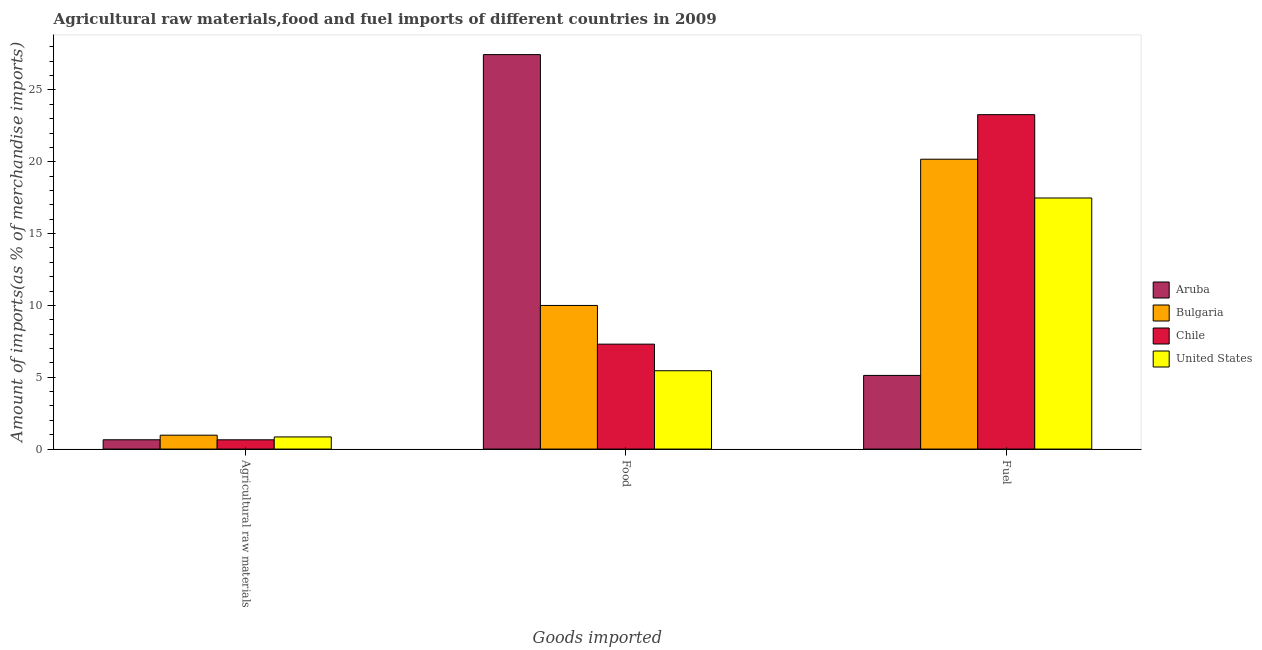How many different coloured bars are there?
Provide a succinct answer. 4. How many groups of bars are there?
Your response must be concise. 3. Are the number of bars per tick equal to the number of legend labels?
Keep it short and to the point. Yes. Are the number of bars on each tick of the X-axis equal?
Offer a terse response. Yes. How many bars are there on the 3rd tick from the left?
Keep it short and to the point. 4. What is the label of the 1st group of bars from the left?
Your response must be concise. Agricultural raw materials. What is the percentage of fuel imports in United States?
Provide a short and direct response. 17.48. Across all countries, what is the maximum percentage of raw materials imports?
Offer a very short reply. 0.97. Across all countries, what is the minimum percentage of food imports?
Give a very brief answer. 5.45. In which country was the percentage of food imports maximum?
Offer a very short reply. Aruba. In which country was the percentage of fuel imports minimum?
Ensure brevity in your answer.  Aruba. What is the total percentage of fuel imports in the graph?
Provide a short and direct response. 66.06. What is the difference between the percentage of fuel imports in Bulgaria and that in Chile?
Your answer should be very brief. -3.1. What is the difference between the percentage of fuel imports in United States and the percentage of raw materials imports in Bulgaria?
Offer a terse response. 16.51. What is the average percentage of fuel imports per country?
Your answer should be compact. 16.51. What is the difference between the percentage of raw materials imports and percentage of food imports in Bulgaria?
Offer a terse response. -9.03. What is the ratio of the percentage of fuel imports in Bulgaria to that in United States?
Offer a terse response. 1.15. What is the difference between the highest and the second highest percentage of fuel imports?
Give a very brief answer. 3.1. What is the difference between the highest and the lowest percentage of food imports?
Ensure brevity in your answer.  22.01. Is the sum of the percentage of raw materials imports in Bulgaria and Aruba greater than the maximum percentage of fuel imports across all countries?
Provide a short and direct response. No. What does the 4th bar from the right in Fuel represents?
Provide a succinct answer. Aruba. Is it the case that in every country, the sum of the percentage of raw materials imports and percentage of food imports is greater than the percentage of fuel imports?
Your answer should be very brief. No. How many bars are there?
Give a very brief answer. 12. Are all the bars in the graph horizontal?
Make the answer very short. No. What is the difference between two consecutive major ticks on the Y-axis?
Offer a very short reply. 5. Are the values on the major ticks of Y-axis written in scientific E-notation?
Offer a terse response. No. What is the title of the graph?
Offer a very short reply. Agricultural raw materials,food and fuel imports of different countries in 2009. Does "Afghanistan" appear as one of the legend labels in the graph?
Offer a terse response. No. What is the label or title of the X-axis?
Keep it short and to the point. Goods imported. What is the label or title of the Y-axis?
Offer a very short reply. Amount of imports(as % of merchandise imports). What is the Amount of imports(as % of merchandise imports) in Aruba in Agricultural raw materials?
Your answer should be very brief. 0.65. What is the Amount of imports(as % of merchandise imports) of Bulgaria in Agricultural raw materials?
Ensure brevity in your answer.  0.97. What is the Amount of imports(as % of merchandise imports) of Chile in Agricultural raw materials?
Your answer should be compact. 0.65. What is the Amount of imports(as % of merchandise imports) of United States in Agricultural raw materials?
Give a very brief answer. 0.85. What is the Amount of imports(as % of merchandise imports) in Aruba in Food?
Offer a very short reply. 27.46. What is the Amount of imports(as % of merchandise imports) in Bulgaria in Food?
Provide a short and direct response. 10. What is the Amount of imports(as % of merchandise imports) of Chile in Food?
Make the answer very short. 7.3. What is the Amount of imports(as % of merchandise imports) in United States in Food?
Provide a succinct answer. 5.45. What is the Amount of imports(as % of merchandise imports) in Aruba in Fuel?
Your answer should be compact. 5.13. What is the Amount of imports(as % of merchandise imports) of Bulgaria in Fuel?
Offer a terse response. 20.18. What is the Amount of imports(as % of merchandise imports) of Chile in Fuel?
Offer a very short reply. 23.28. What is the Amount of imports(as % of merchandise imports) in United States in Fuel?
Keep it short and to the point. 17.48. Across all Goods imported, what is the maximum Amount of imports(as % of merchandise imports) in Aruba?
Provide a short and direct response. 27.46. Across all Goods imported, what is the maximum Amount of imports(as % of merchandise imports) of Bulgaria?
Keep it short and to the point. 20.18. Across all Goods imported, what is the maximum Amount of imports(as % of merchandise imports) in Chile?
Provide a short and direct response. 23.28. Across all Goods imported, what is the maximum Amount of imports(as % of merchandise imports) of United States?
Offer a very short reply. 17.48. Across all Goods imported, what is the minimum Amount of imports(as % of merchandise imports) of Aruba?
Offer a terse response. 0.65. Across all Goods imported, what is the minimum Amount of imports(as % of merchandise imports) in Bulgaria?
Offer a very short reply. 0.97. Across all Goods imported, what is the minimum Amount of imports(as % of merchandise imports) of Chile?
Offer a terse response. 0.65. Across all Goods imported, what is the minimum Amount of imports(as % of merchandise imports) in United States?
Your answer should be compact. 0.85. What is the total Amount of imports(as % of merchandise imports) in Aruba in the graph?
Make the answer very short. 33.23. What is the total Amount of imports(as % of merchandise imports) of Bulgaria in the graph?
Provide a short and direct response. 31.14. What is the total Amount of imports(as % of merchandise imports) in Chile in the graph?
Offer a very short reply. 31.23. What is the total Amount of imports(as % of merchandise imports) of United States in the graph?
Provide a succinct answer. 23.78. What is the difference between the Amount of imports(as % of merchandise imports) of Aruba in Agricultural raw materials and that in Food?
Offer a terse response. -26.81. What is the difference between the Amount of imports(as % of merchandise imports) of Bulgaria in Agricultural raw materials and that in Food?
Offer a very short reply. -9.03. What is the difference between the Amount of imports(as % of merchandise imports) of Chile in Agricultural raw materials and that in Food?
Offer a terse response. -6.66. What is the difference between the Amount of imports(as % of merchandise imports) in United States in Agricultural raw materials and that in Food?
Offer a terse response. -4.61. What is the difference between the Amount of imports(as % of merchandise imports) in Aruba in Agricultural raw materials and that in Fuel?
Your response must be concise. -4.48. What is the difference between the Amount of imports(as % of merchandise imports) of Bulgaria in Agricultural raw materials and that in Fuel?
Your answer should be compact. -19.21. What is the difference between the Amount of imports(as % of merchandise imports) in Chile in Agricultural raw materials and that in Fuel?
Keep it short and to the point. -22.63. What is the difference between the Amount of imports(as % of merchandise imports) in United States in Agricultural raw materials and that in Fuel?
Provide a succinct answer. -16.63. What is the difference between the Amount of imports(as % of merchandise imports) of Aruba in Food and that in Fuel?
Make the answer very short. 22.33. What is the difference between the Amount of imports(as % of merchandise imports) of Bulgaria in Food and that in Fuel?
Give a very brief answer. -10.18. What is the difference between the Amount of imports(as % of merchandise imports) in Chile in Food and that in Fuel?
Keep it short and to the point. -15.97. What is the difference between the Amount of imports(as % of merchandise imports) of United States in Food and that in Fuel?
Your answer should be compact. -12.03. What is the difference between the Amount of imports(as % of merchandise imports) in Aruba in Agricultural raw materials and the Amount of imports(as % of merchandise imports) in Bulgaria in Food?
Provide a succinct answer. -9.35. What is the difference between the Amount of imports(as % of merchandise imports) in Aruba in Agricultural raw materials and the Amount of imports(as % of merchandise imports) in Chile in Food?
Your answer should be very brief. -6.66. What is the difference between the Amount of imports(as % of merchandise imports) in Aruba in Agricultural raw materials and the Amount of imports(as % of merchandise imports) in United States in Food?
Offer a terse response. -4.8. What is the difference between the Amount of imports(as % of merchandise imports) in Bulgaria in Agricultural raw materials and the Amount of imports(as % of merchandise imports) in Chile in Food?
Your answer should be very brief. -6.34. What is the difference between the Amount of imports(as % of merchandise imports) of Bulgaria in Agricultural raw materials and the Amount of imports(as % of merchandise imports) of United States in Food?
Make the answer very short. -4.49. What is the difference between the Amount of imports(as % of merchandise imports) in Chile in Agricultural raw materials and the Amount of imports(as % of merchandise imports) in United States in Food?
Ensure brevity in your answer.  -4.81. What is the difference between the Amount of imports(as % of merchandise imports) of Aruba in Agricultural raw materials and the Amount of imports(as % of merchandise imports) of Bulgaria in Fuel?
Your answer should be compact. -19.53. What is the difference between the Amount of imports(as % of merchandise imports) of Aruba in Agricultural raw materials and the Amount of imports(as % of merchandise imports) of Chile in Fuel?
Ensure brevity in your answer.  -22.63. What is the difference between the Amount of imports(as % of merchandise imports) of Aruba in Agricultural raw materials and the Amount of imports(as % of merchandise imports) of United States in Fuel?
Offer a very short reply. -16.83. What is the difference between the Amount of imports(as % of merchandise imports) in Bulgaria in Agricultural raw materials and the Amount of imports(as % of merchandise imports) in Chile in Fuel?
Give a very brief answer. -22.31. What is the difference between the Amount of imports(as % of merchandise imports) in Bulgaria in Agricultural raw materials and the Amount of imports(as % of merchandise imports) in United States in Fuel?
Your response must be concise. -16.51. What is the difference between the Amount of imports(as % of merchandise imports) in Chile in Agricultural raw materials and the Amount of imports(as % of merchandise imports) in United States in Fuel?
Keep it short and to the point. -16.83. What is the difference between the Amount of imports(as % of merchandise imports) of Aruba in Food and the Amount of imports(as % of merchandise imports) of Bulgaria in Fuel?
Keep it short and to the point. 7.28. What is the difference between the Amount of imports(as % of merchandise imports) in Aruba in Food and the Amount of imports(as % of merchandise imports) in Chile in Fuel?
Your answer should be very brief. 4.18. What is the difference between the Amount of imports(as % of merchandise imports) in Aruba in Food and the Amount of imports(as % of merchandise imports) in United States in Fuel?
Keep it short and to the point. 9.98. What is the difference between the Amount of imports(as % of merchandise imports) of Bulgaria in Food and the Amount of imports(as % of merchandise imports) of Chile in Fuel?
Ensure brevity in your answer.  -13.28. What is the difference between the Amount of imports(as % of merchandise imports) in Bulgaria in Food and the Amount of imports(as % of merchandise imports) in United States in Fuel?
Give a very brief answer. -7.48. What is the difference between the Amount of imports(as % of merchandise imports) in Chile in Food and the Amount of imports(as % of merchandise imports) in United States in Fuel?
Give a very brief answer. -10.17. What is the average Amount of imports(as % of merchandise imports) in Aruba per Goods imported?
Provide a succinct answer. 11.08. What is the average Amount of imports(as % of merchandise imports) of Bulgaria per Goods imported?
Provide a succinct answer. 10.38. What is the average Amount of imports(as % of merchandise imports) in Chile per Goods imported?
Keep it short and to the point. 10.41. What is the average Amount of imports(as % of merchandise imports) of United States per Goods imported?
Your answer should be compact. 7.92. What is the difference between the Amount of imports(as % of merchandise imports) of Aruba and Amount of imports(as % of merchandise imports) of Bulgaria in Agricultural raw materials?
Make the answer very short. -0.32. What is the difference between the Amount of imports(as % of merchandise imports) of Aruba and Amount of imports(as % of merchandise imports) of Chile in Agricultural raw materials?
Your answer should be very brief. 0. What is the difference between the Amount of imports(as % of merchandise imports) in Aruba and Amount of imports(as % of merchandise imports) in United States in Agricultural raw materials?
Ensure brevity in your answer.  -0.2. What is the difference between the Amount of imports(as % of merchandise imports) of Bulgaria and Amount of imports(as % of merchandise imports) of Chile in Agricultural raw materials?
Your answer should be very brief. 0.32. What is the difference between the Amount of imports(as % of merchandise imports) of Bulgaria and Amount of imports(as % of merchandise imports) of United States in Agricultural raw materials?
Your response must be concise. 0.12. What is the difference between the Amount of imports(as % of merchandise imports) in Chile and Amount of imports(as % of merchandise imports) in United States in Agricultural raw materials?
Ensure brevity in your answer.  -0.2. What is the difference between the Amount of imports(as % of merchandise imports) in Aruba and Amount of imports(as % of merchandise imports) in Bulgaria in Food?
Offer a terse response. 17.46. What is the difference between the Amount of imports(as % of merchandise imports) of Aruba and Amount of imports(as % of merchandise imports) of Chile in Food?
Your response must be concise. 20.15. What is the difference between the Amount of imports(as % of merchandise imports) in Aruba and Amount of imports(as % of merchandise imports) in United States in Food?
Your answer should be very brief. 22.01. What is the difference between the Amount of imports(as % of merchandise imports) in Bulgaria and Amount of imports(as % of merchandise imports) in Chile in Food?
Offer a terse response. 2.69. What is the difference between the Amount of imports(as % of merchandise imports) of Bulgaria and Amount of imports(as % of merchandise imports) of United States in Food?
Make the answer very short. 4.55. What is the difference between the Amount of imports(as % of merchandise imports) in Chile and Amount of imports(as % of merchandise imports) in United States in Food?
Provide a short and direct response. 1.85. What is the difference between the Amount of imports(as % of merchandise imports) in Aruba and Amount of imports(as % of merchandise imports) in Bulgaria in Fuel?
Ensure brevity in your answer.  -15.05. What is the difference between the Amount of imports(as % of merchandise imports) in Aruba and Amount of imports(as % of merchandise imports) in Chile in Fuel?
Your answer should be compact. -18.15. What is the difference between the Amount of imports(as % of merchandise imports) of Aruba and Amount of imports(as % of merchandise imports) of United States in Fuel?
Keep it short and to the point. -12.35. What is the difference between the Amount of imports(as % of merchandise imports) of Bulgaria and Amount of imports(as % of merchandise imports) of Chile in Fuel?
Your answer should be very brief. -3.1. What is the difference between the Amount of imports(as % of merchandise imports) in Bulgaria and Amount of imports(as % of merchandise imports) in United States in Fuel?
Keep it short and to the point. 2.7. What is the difference between the Amount of imports(as % of merchandise imports) in Chile and Amount of imports(as % of merchandise imports) in United States in Fuel?
Make the answer very short. 5.8. What is the ratio of the Amount of imports(as % of merchandise imports) of Aruba in Agricultural raw materials to that in Food?
Make the answer very short. 0.02. What is the ratio of the Amount of imports(as % of merchandise imports) in Bulgaria in Agricultural raw materials to that in Food?
Offer a very short reply. 0.1. What is the ratio of the Amount of imports(as % of merchandise imports) in Chile in Agricultural raw materials to that in Food?
Provide a short and direct response. 0.09. What is the ratio of the Amount of imports(as % of merchandise imports) in United States in Agricultural raw materials to that in Food?
Ensure brevity in your answer.  0.16. What is the ratio of the Amount of imports(as % of merchandise imports) in Aruba in Agricultural raw materials to that in Fuel?
Provide a succinct answer. 0.13. What is the ratio of the Amount of imports(as % of merchandise imports) of Bulgaria in Agricultural raw materials to that in Fuel?
Make the answer very short. 0.05. What is the ratio of the Amount of imports(as % of merchandise imports) of Chile in Agricultural raw materials to that in Fuel?
Provide a succinct answer. 0.03. What is the ratio of the Amount of imports(as % of merchandise imports) in United States in Agricultural raw materials to that in Fuel?
Offer a very short reply. 0.05. What is the ratio of the Amount of imports(as % of merchandise imports) of Aruba in Food to that in Fuel?
Your answer should be very brief. 5.36. What is the ratio of the Amount of imports(as % of merchandise imports) in Bulgaria in Food to that in Fuel?
Offer a terse response. 0.5. What is the ratio of the Amount of imports(as % of merchandise imports) in Chile in Food to that in Fuel?
Your answer should be compact. 0.31. What is the ratio of the Amount of imports(as % of merchandise imports) in United States in Food to that in Fuel?
Ensure brevity in your answer.  0.31. What is the difference between the highest and the second highest Amount of imports(as % of merchandise imports) of Aruba?
Provide a short and direct response. 22.33. What is the difference between the highest and the second highest Amount of imports(as % of merchandise imports) in Bulgaria?
Make the answer very short. 10.18. What is the difference between the highest and the second highest Amount of imports(as % of merchandise imports) in Chile?
Your response must be concise. 15.97. What is the difference between the highest and the second highest Amount of imports(as % of merchandise imports) in United States?
Ensure brevity in your answer.  12.03. What is the difference between the highest and the lowest Amount of imports(as % of merchandise imports) of Aruba?
Your answer should be very brief. 26.81. What is the difference between the highest and the lowest Amount of imports(as % of merchandise imports) of Bulgaria?
Offer a very short reply. 19.21. What is the difference between the highest and the lowest Amount of imports(as % of merchandise imports) in Chile?
Keep it short and to the point. 22.63. What is the difference between the highest and the lowest Amount of imports(as % of merchandise imports) of United States?
Ensure brevity in your answer.  16.63. 